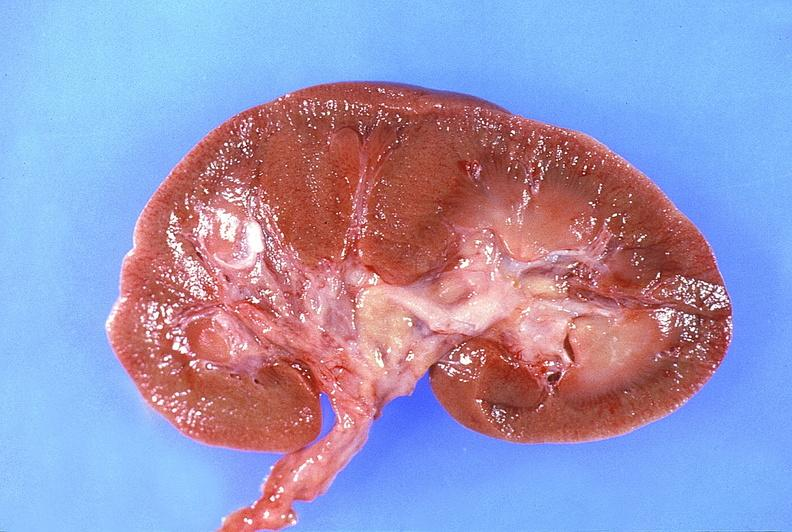where is this?
Answer the question using a single word or phrase. Urinary 